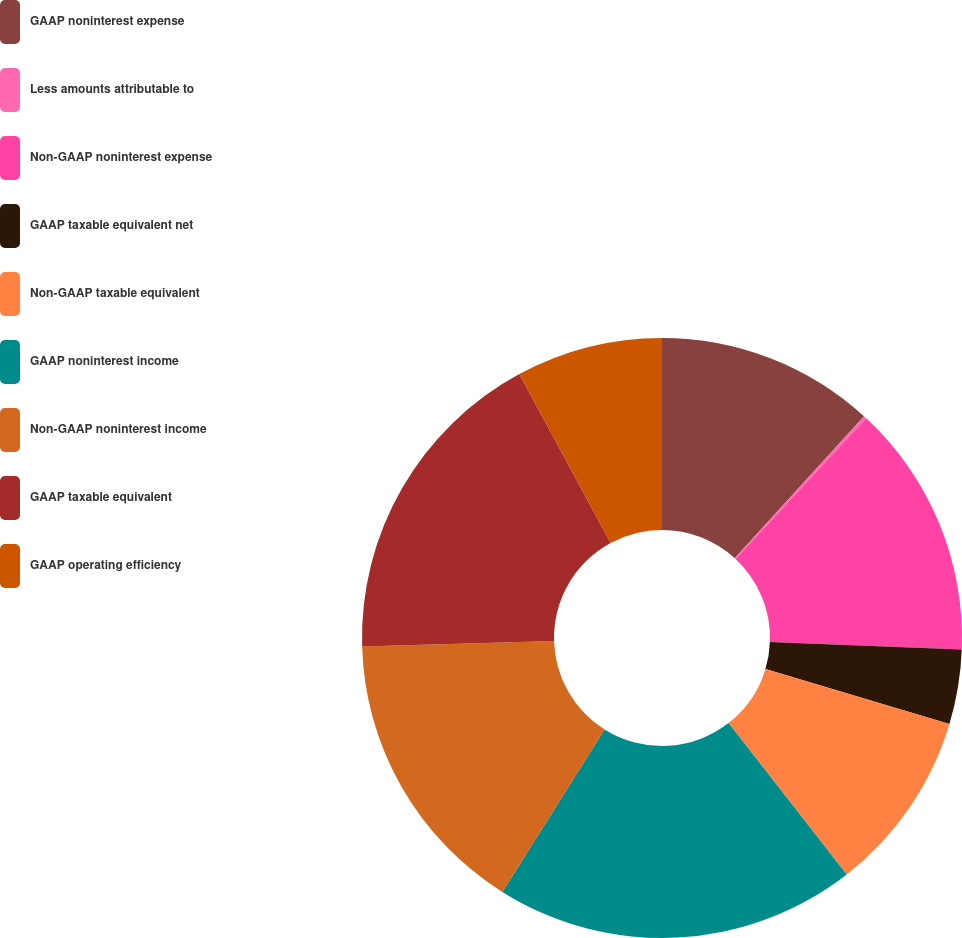Convert chart. <chart><loc_0><loc_0><loc_500><loc_500><pie_chart><fcel>GAAP noninterest expense<fcel>Less amounts attributable to<fcel>Non-GAAP noninterest expense<fcel>GAAP taxable equivalent net<fcel>Non-GAAP taxable equivalent<fcel>GAAP noninterest income<fcel>Non-GAAP noninterest income<fcel>GAAP taxable equivalent<fcel>GAAP operating efficiency<nl><fcel>11.76%<fcel>0.16%<fcel>13.69%<fcel>4.02%<fcel>9.82%<fcel>19.49%<fcel>15.62%<fcel>17.56%<fcel>7.89%<nl></chart> 